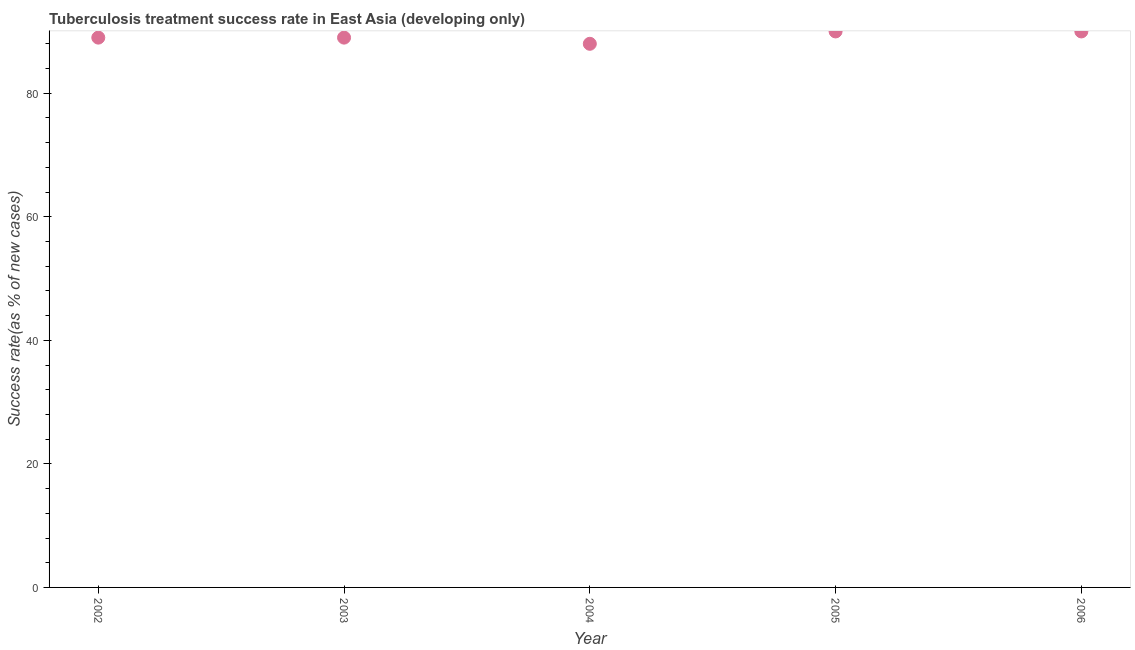What is the tuberculosis treatment success rate in 2006?
Give a very brief answer. 90. Across all years, what is the maximum tuberculosis treatment success rate?
Offer a very short reply. 90. Across all years, what is the minimum tuberculosis treatment success rate?
Make the answer very short. 88. In which year was the tuberculosis treatment success rate maximum?
Your answer should be compact. 2005. In which year was the tuberculosis treatment success rate minimum?
Keep it short and to the point. 2004. What is the sum of the tuberculosis treatment success rate?
Offer a very short reply. 446. What is the difference between the tuberculosis treatment success rate in 2002 and 2005?
Provide a short and direct response. -1. What is the average tuberculosis treatment success rate per year?
Your response must be concise. 89.2. What is the median tuberculosis treatment success rate?
Make the answer very short. 89. Do a majority of the years between 2004 and 2002 (inclusive) have tuberculosis treatment success rate greater than 56 %?
Provide a succinct answer. No. Is the difference between the tuberculosis treatment success rate in 2004 and 2005 greater than the difference between any two years?
Your response must be concise. Yes. What is the difference between the highest and the lowest tuberculosis treatment success rate?
Your response must be concise. 2. In how many years, is the tuberculosis treatment success rate greater than the average tuberculosis treatment success rate taken over all years?
Offer a terse response. 2. Does the tuberculosis treatment success rate monotonically increase over the years?
Your answer should be compact. No. How many years are there in the graph?
Provide a succinct answer. 5. Are the values on the major ticks of Y-axis written in scientific E-notation?
Provide a succinct answer. No. Does the graph contain any zero values?
Your answer should be compact. No. What is the title of the graph?
Your answer should be very brief. Tuberculosis treatment success rate in East Asia (developing only). What is the label or title of the X-axis?
Give a very brief answer. Year. What is the label or title of the Y-axis?
Keep it short and to the point. Success rate(as % of new cases). What is the Success rate(as % of new cases) in 2002?
Give a very brief answer. 89. What is the Success rate(as % of new cases) in 2003?
Provide a short and direct response. 89. What is the Success rate(as % of new cases) in 2004?
Provide a succinct answer. 88. What is the Success rate(as % of new cases) in 2006?
Offer a terse response. 90. What is the difference between the Success rate(as % of new cases) in 2002 and 2003?
Keep it short and to the point. 0. What is the difference between the Success rate(as % of new cases) in 2003 and 2005?
Offer a very short reply. -1. What is the ratio of the Success rate(as % of new cases) in 2002 to that in 2003?
Offer a terse response. 1. What is the ratio of the Success rate(as % of new cases) in 2002 to that in 2004?
Your answer should be very brief. 1.01. What is the ratio of the Success rate(as % of new cases) in 2002 to that in 2005?
Give a very brief answer. 0.99. What is the ratio of the Success rate(as % of new cases) in 2003 to that in 2004?
Offer a terse response. 1.01. What is the ratio of the Success rate(as % of new cases) in 2003 to that in 2005?
Ensure brevity in your answer.  0.99. What is the ratio of the Success rate(as % of new cases) in 2004 to that in 2005?
Provide a succinct answer. 0.98. What is the ratio of the Success rate(as % of new cases) in 2004 to that in 2006?
Your answer should be very brief. 0.98. 